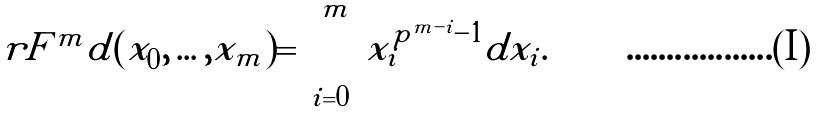<formula> <loc_0><loc_0><loc_500><loc_500>\ r F ^ { m } d ( x _ { 0 } , \dots , x _ { m } ) = \sum _ { i = 0 } ^ { m } x _ { i } ^ { p ^ { m - i } - 1 } d x _ { i } .</formula> 